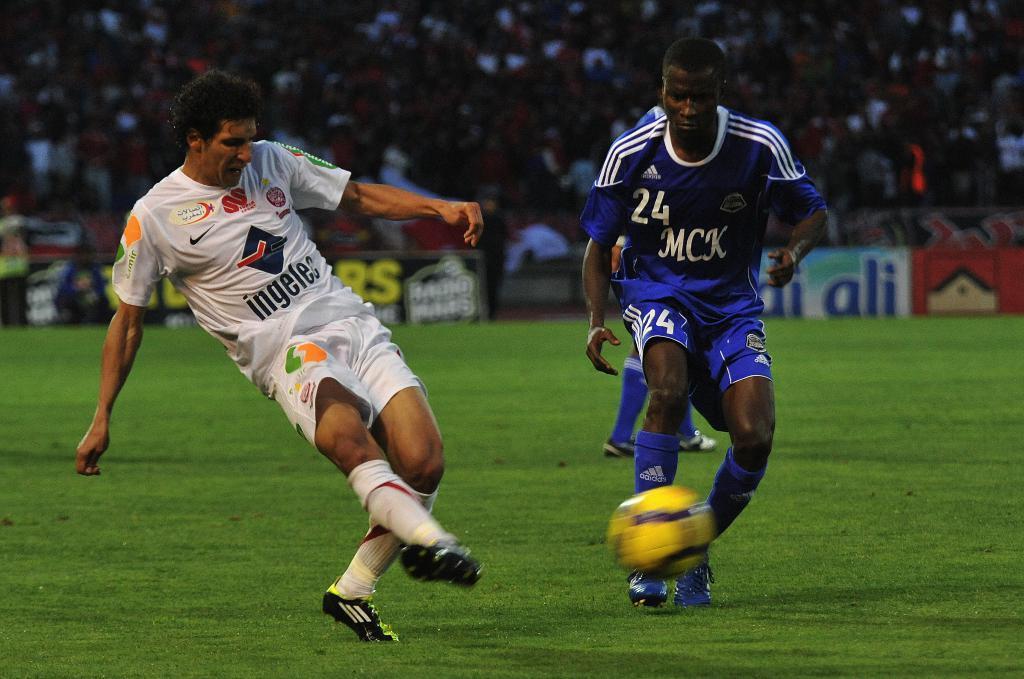Please provide a concise description of this image. It is a ground the people who are inside the game are playing football the ball is of yellow color in the background there are crowd who are watching the game. 